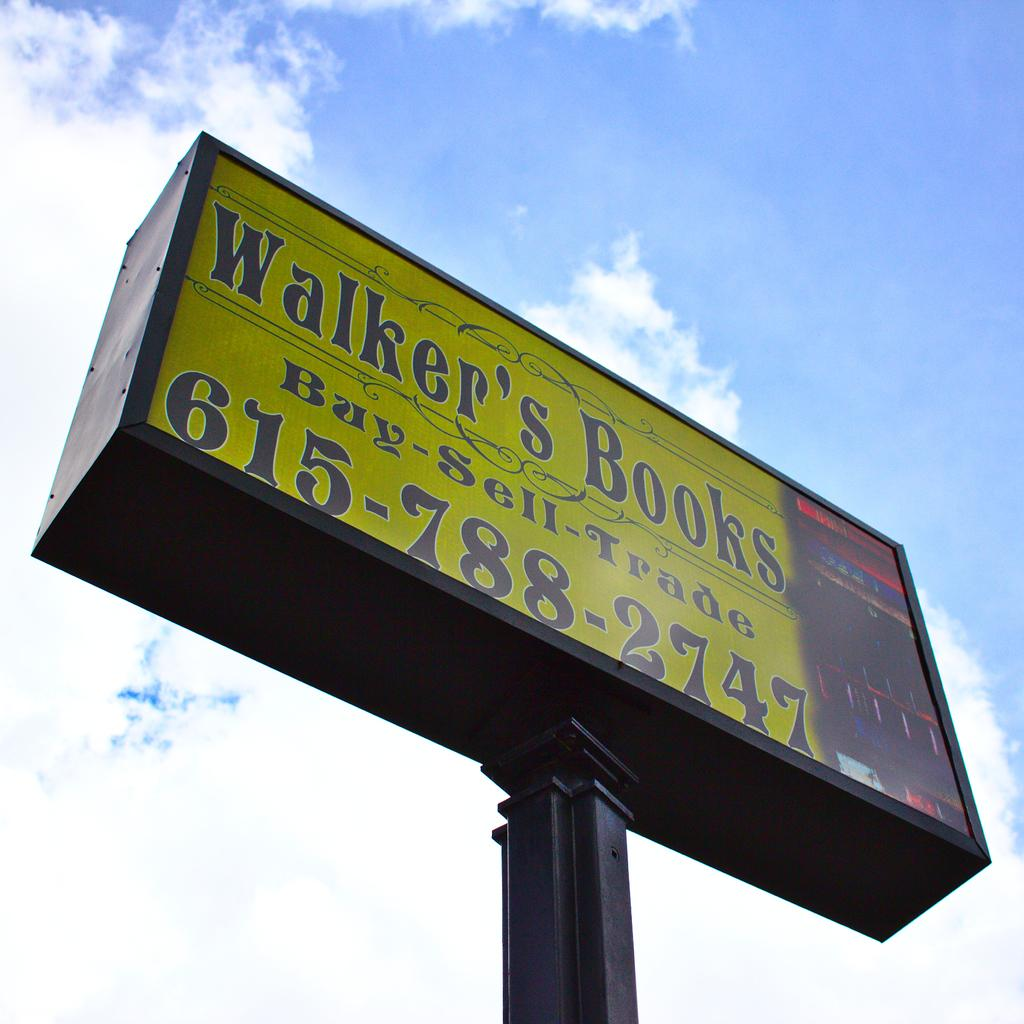Provide a one-sentence caption for the provided image. Walker's Books will buy, sell and trade other books. 